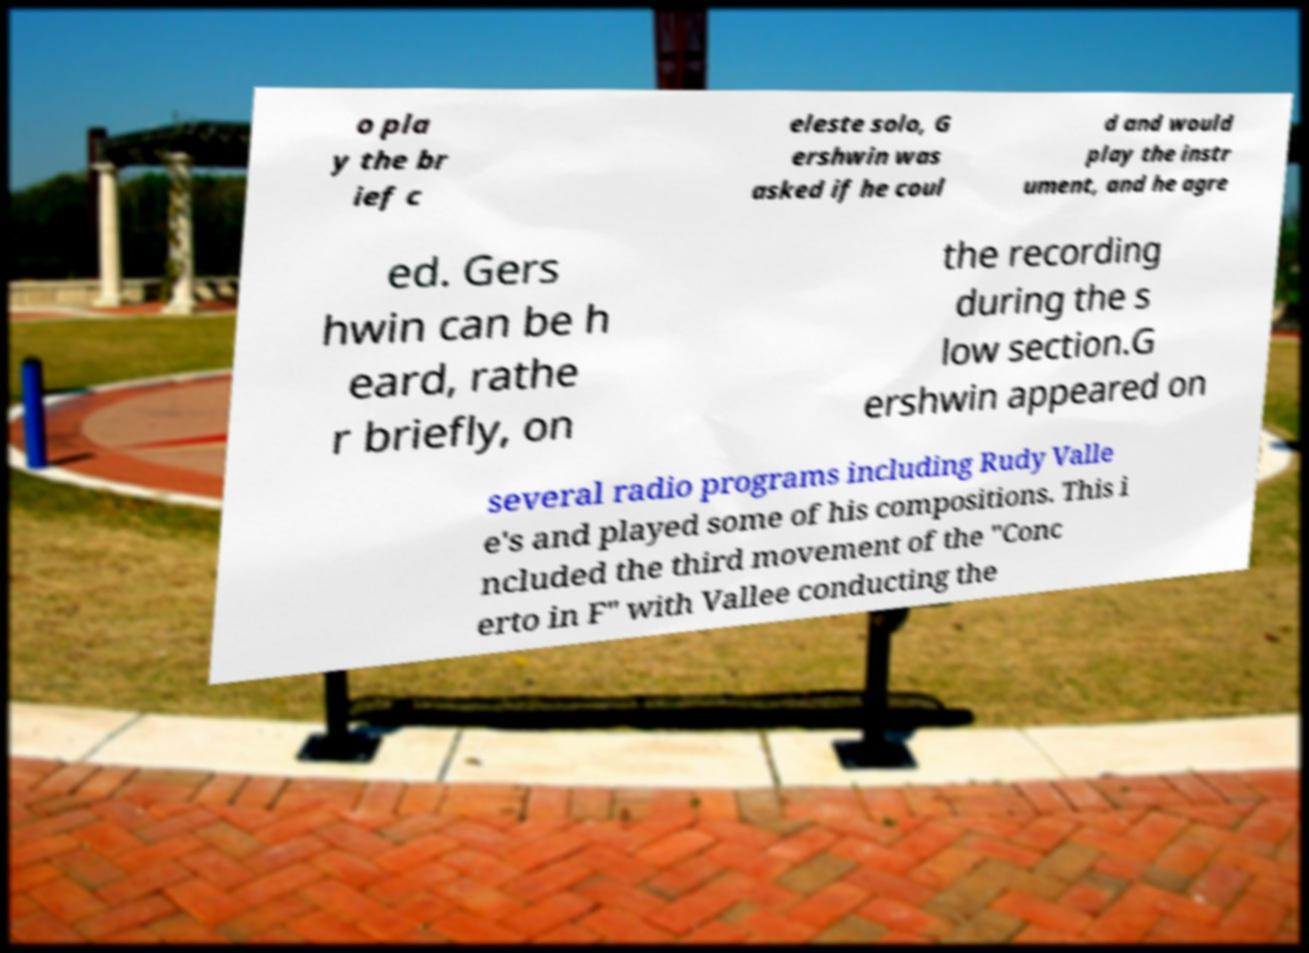Could you extract and type out the text from this image? o pla y the br ief c eleste solo, G ershwin was asked if he coul d and would play the instr ument, and he agre ed. Gers hwin can be h eard, rathe r briefly, on the recording during the s low section.G ershwin appeared on several radio programs including Rudy Valle e's and played some of his compositions. This i ncluded the third movement of the "Conc erto in F" with Vallee conducting the 